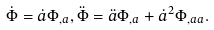<formula> <loc_0><loc_0><loc_500><loc_500>\dot { \Phi } = \dot { a } \Phi _ { , a } , \ddot { \Phi } = \ddot { a } \Phi _ { , a } + \dot { a } ^ { 2 } \Phi _ { , a a } .</formula> 